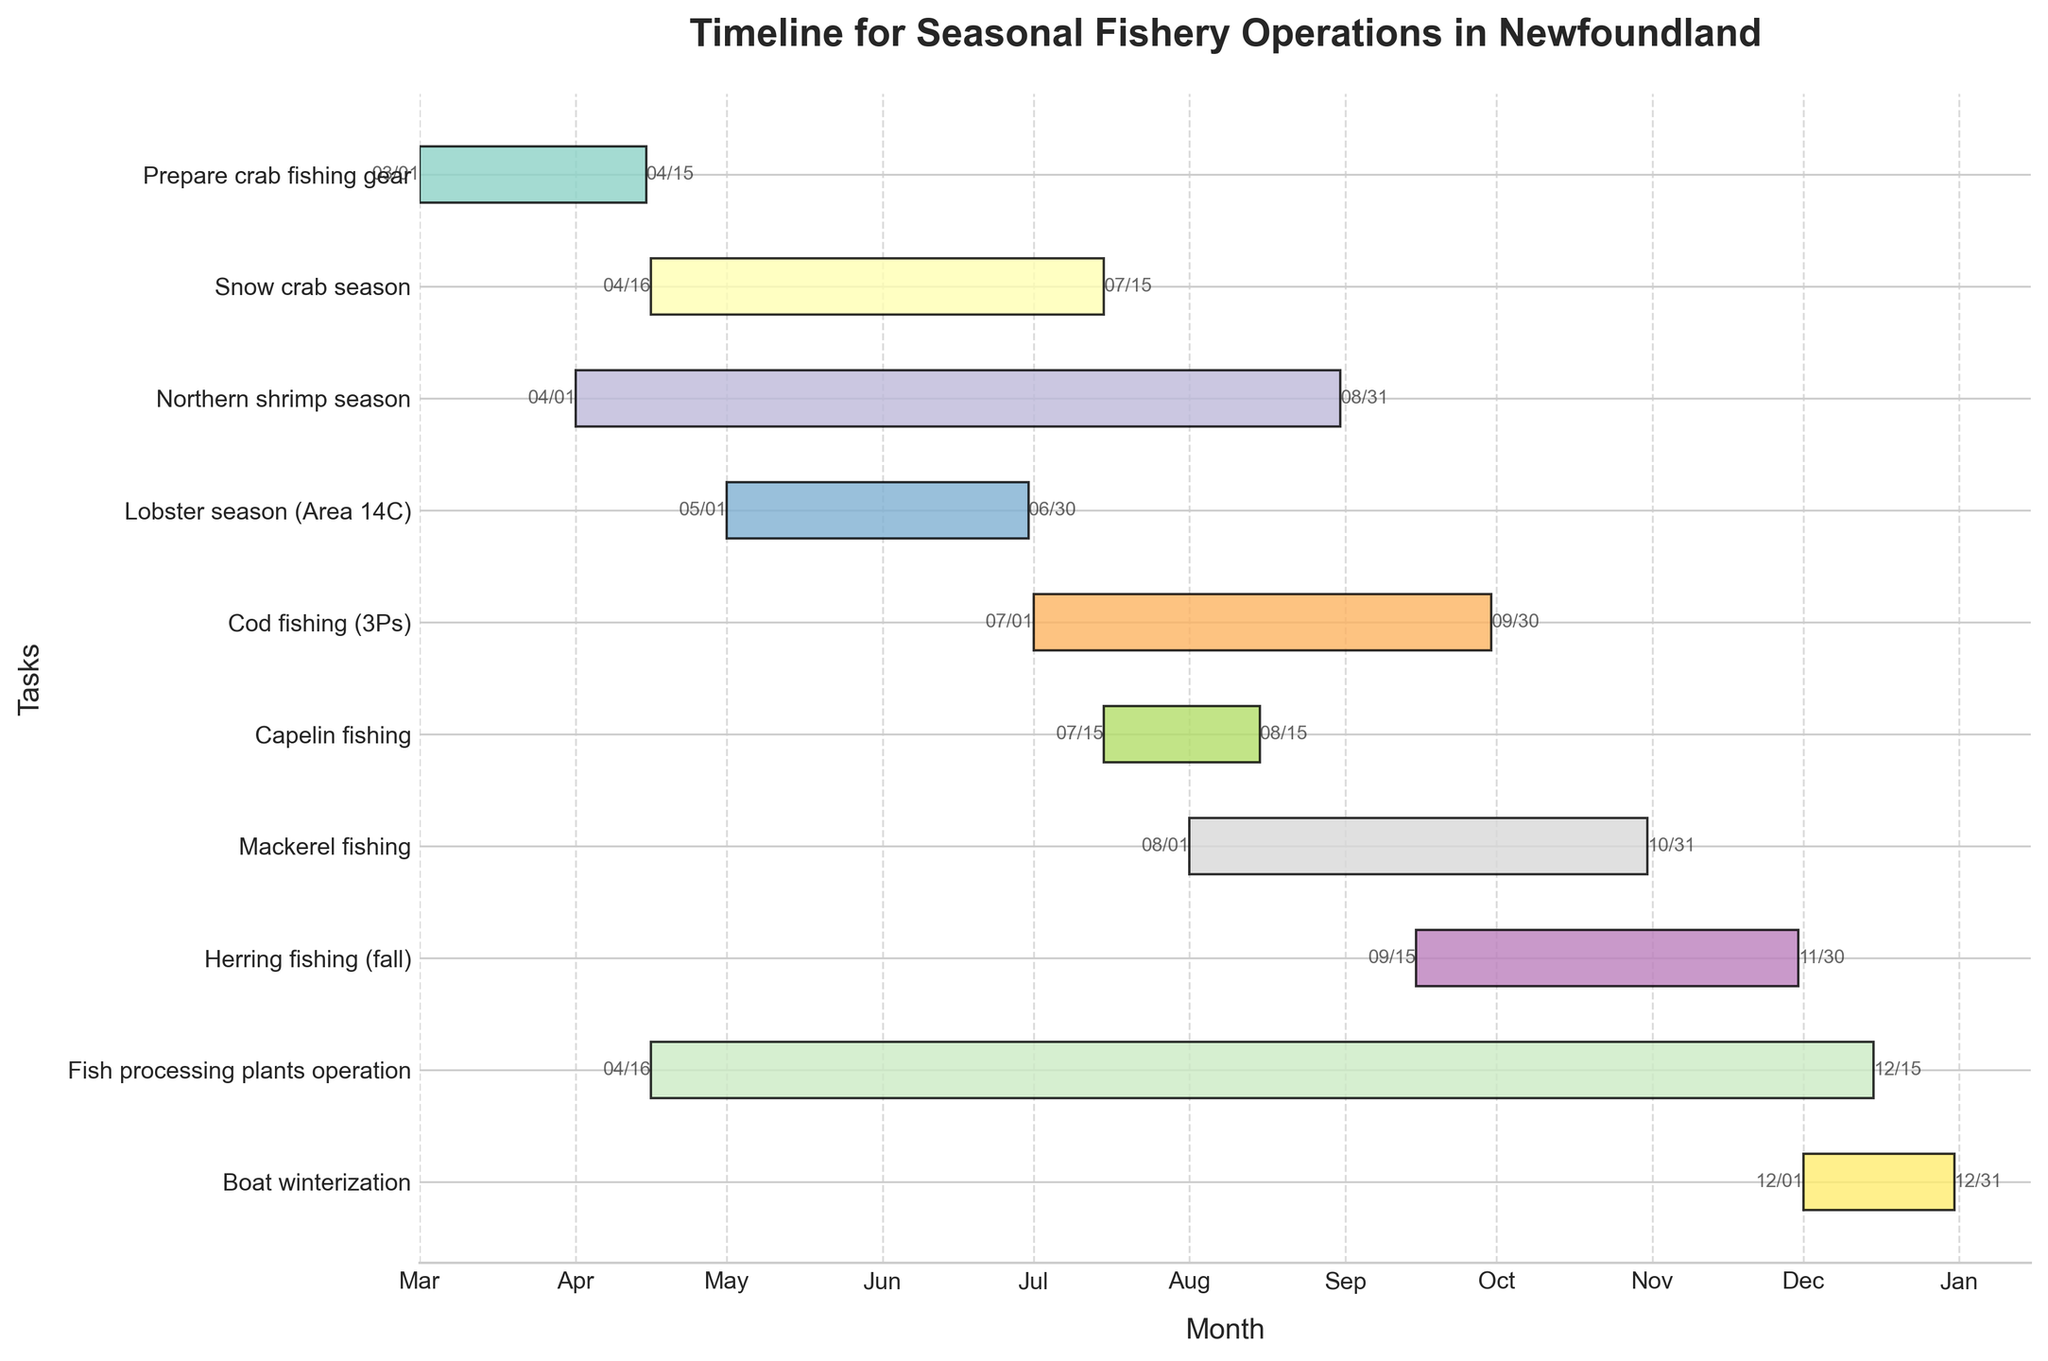What is the title of the chart? The title is usually located at the top of the chart, summarizing the content. In this case, it states the focus of the operations plotted on the Gantt Chart.
Answer: Timeline for Seasonal Fishery Operations in Newfoundland Which task has the shortest duration? This can be determined by comparing the lengths of the bars representing each task on the Gantt Chart. The shortest bar corresponds to the task with the shortest duration.
Answer: Capelin fishing When does the Cod fishing (3Ps) season start and end? Look for the Cod fishing (3Ps) bar on the Gantt Chart and read the dates at the beginning and end of this bar.
Answer: Starts on July 1 and ends on September 30 How long is the Mackerel fishing season? Check the length of the Mackerel fishing bar on the Gantt Chart and calculate the number of days between the start and end dates.
Answer: 92 days Which tasks are ongoing simultaneously in May? Identify the bars that cover the month of May and list those tasks.
Answer: Northern shrimp season, Lobster season (Area 14C), Snow crab season, Fish processing plants operation Compare the durations of the Snow crab season and the Cod fishing (3Ps) season. Which one lasts longer? Look at the bars for Snow crab season and Cod fishing (3Ps), comparing their lengths, or calculate the duration of each by subtracting the start date from the end date.
Answer: Snow crab season What is the difference in duration between the Lobster season (Area 14C) and the Capelin fishing season? Calculate the duration of both Lobster season (Area 14C) and Capelin fishing by finding the number of days each bar spans, then subtract the shorter duration from the longer one.
Answer: 45 days Which seasons span the entirety of August? Identify the bars that extend from the beginning to the end of August.
Answer: Northern shrimp season, Capelin fishing, Mackerel fishing, Fish processing plants operation What activity begins the latest in the year? Look for the task bar that starts near the end of the Gantt Chart and read the date at the beginning of this bar.
Answer: Boat winterization During which months is the Fish processing plants operation active? Check the Fish processing plants operation bar and note the months it spans from start to end.
Answer: April to December 